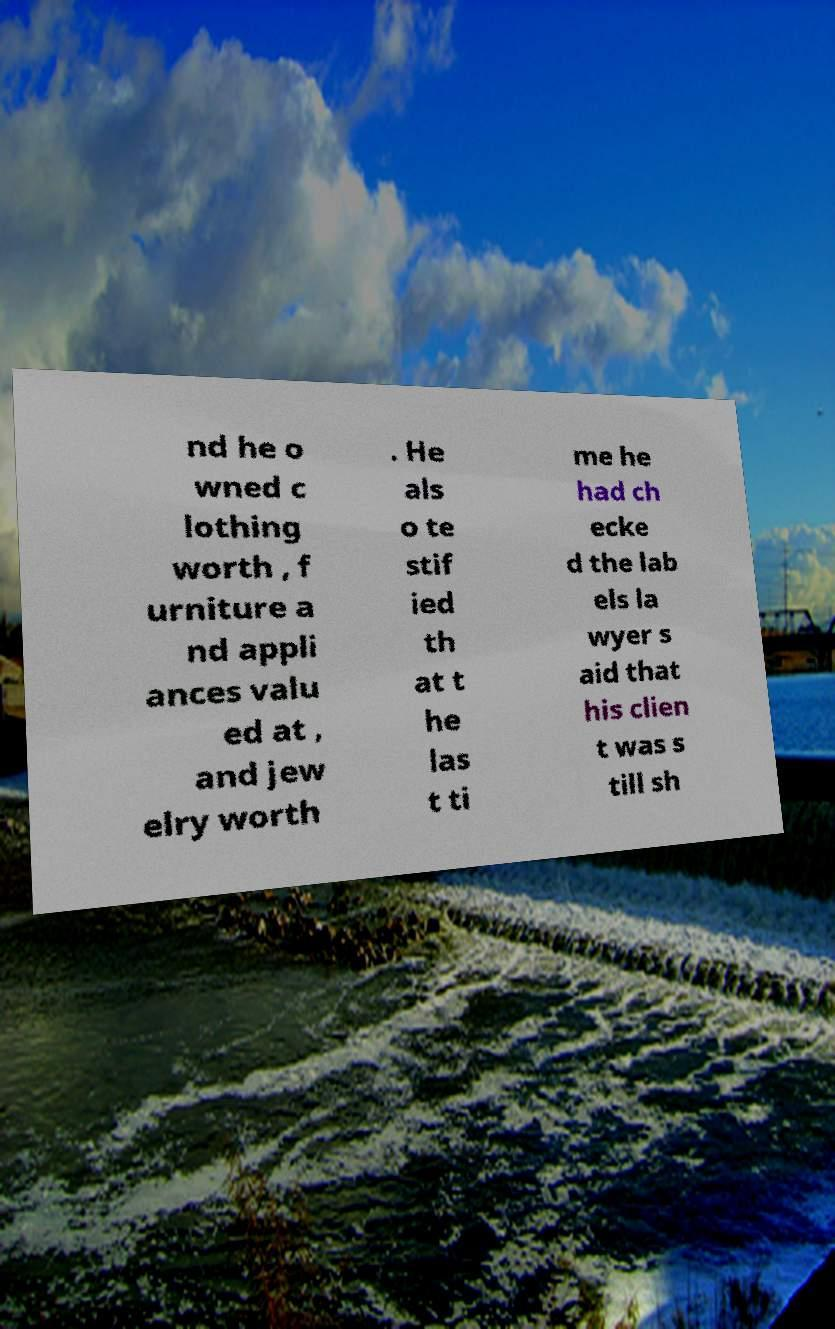Could you extract and type out the text from this image? nd he o wned c lothing worth , f urniture a nd appli ances valu ed at , and jew elry worth . He als o te stif ied th at t he las t ti me he had ch ecke d the lab els la wyer s aid that his clien t was s till sh 